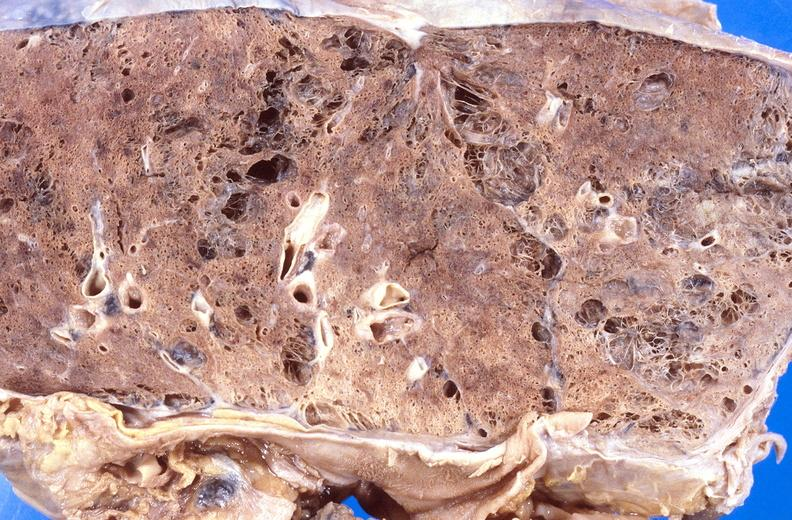where is this?
Answer the question using a single word or phrase. Lung 